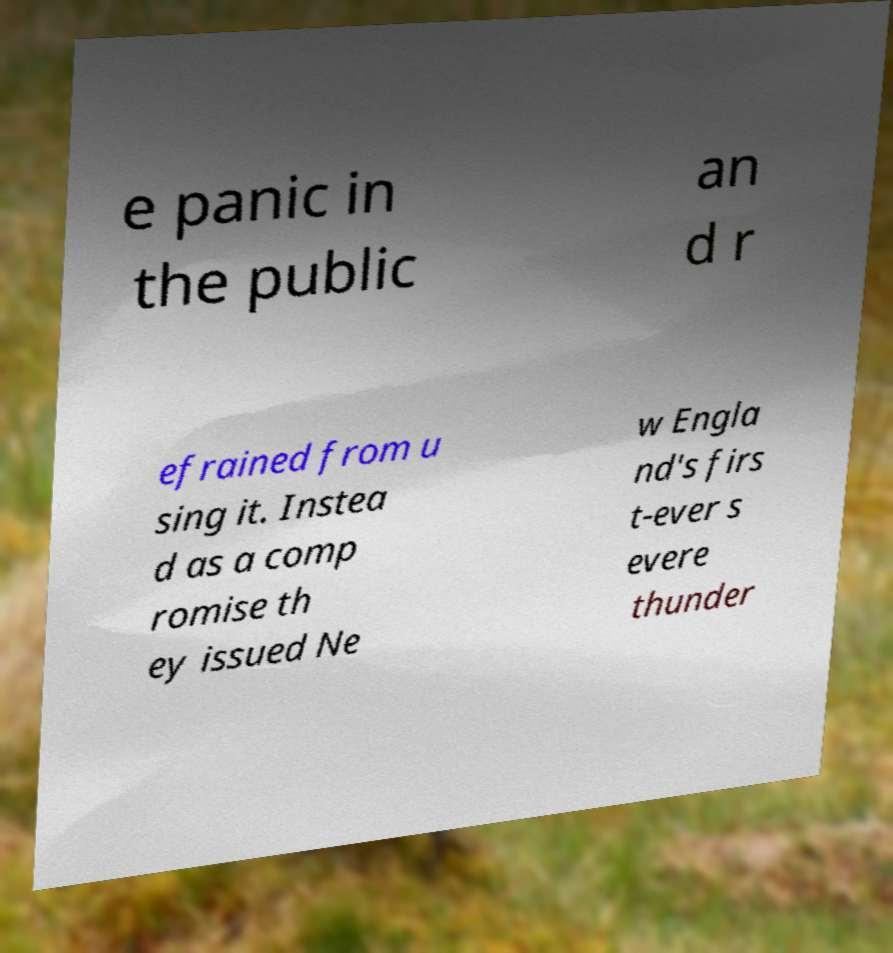There's text embedded in this image that I need extracted. Can you transcribe it verbatim? e panic in the public an d r efrained from u sing it. Instea d as a comp romise th ey issued Ne w Engla nd's firs t-ever s evere thunder 